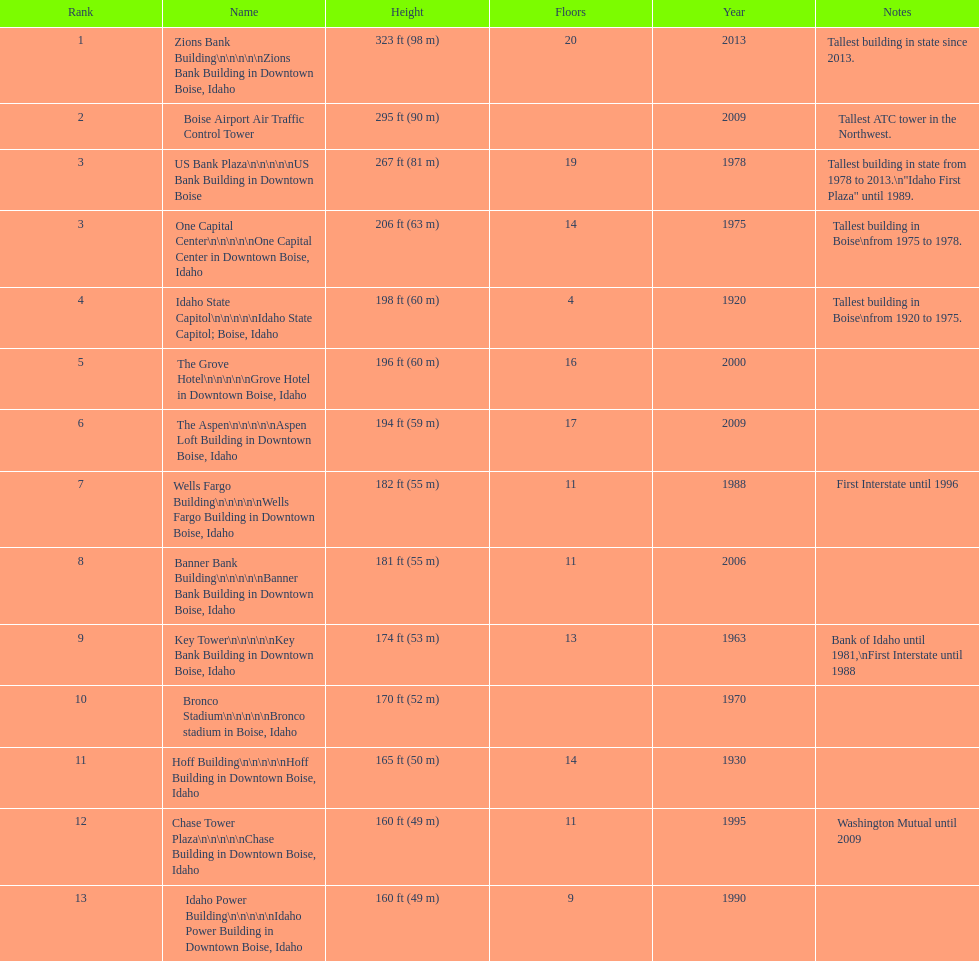How many floors does the tallest building have? 20. 